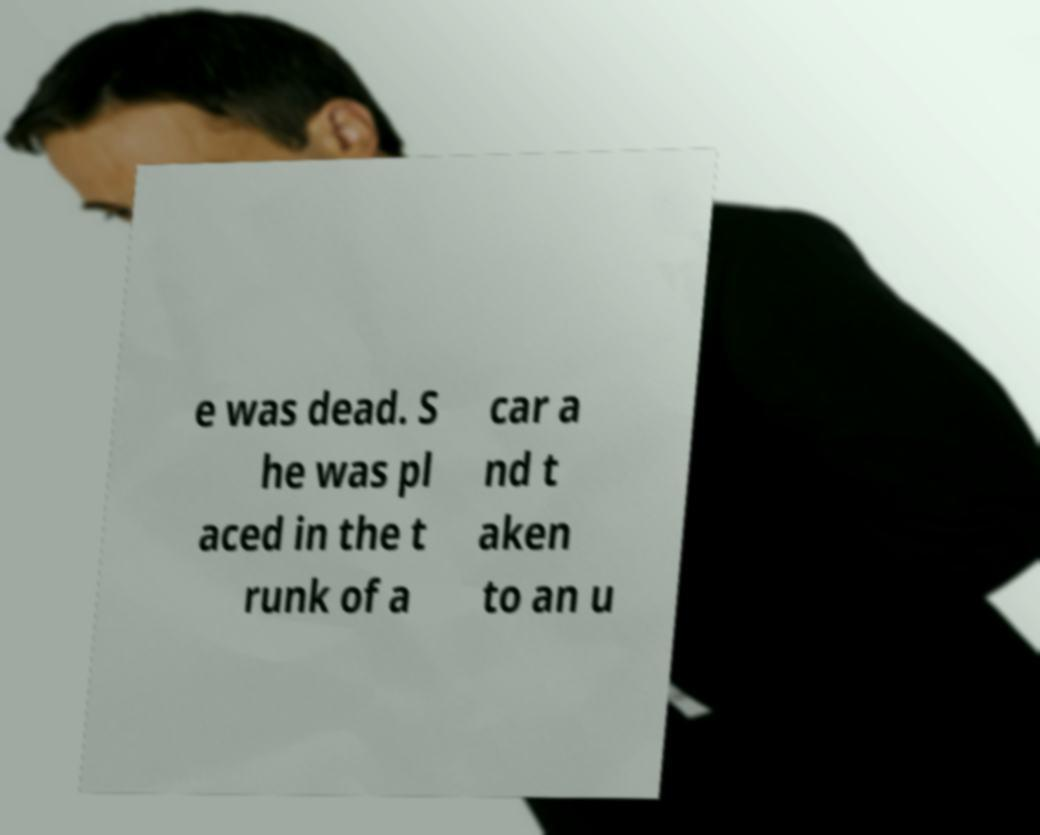Please identify and transcribe the text found in this image. e was dead. S he was pl aced in the t runk of a car a nd t aken to an u 